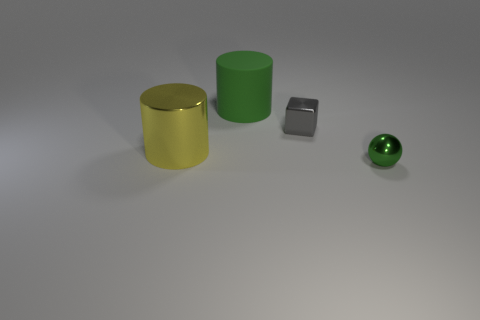There is a yellow object that is the same shape as the big green rubber object; what is its size?
Keep it short and to the point. Large. There is a tiny object that is behind the tiny green shiny thing; what is its shape?
Your answer should be compact. Cube. There is a green shiny thing; what shape is it?
Your answer should be very brief. Sphere. What is the size of the ball that is the same color as the rubber thing?
Offer a terse response. Small. Is there a big green ball made of the same material as the large yellow cylinder?
Provide a short and direct response. No. Is the number of tiny rubber objects greater than the number of big green rubber things?
Offer a very short reply. No. Is the material of the green cylinder the same as the ball?
Your answer should be very brief. No. How many shiny objects are either large brown cylinders or tiny gray blocks?
Keep it short and to the point. 1. The shiny thing that is the same size as the green matte object is what color?
Your answer should be compact. Yellow. What number of large yellow objects are the same shape as the gray metallic thing?
Your answer should be compact. 0. 